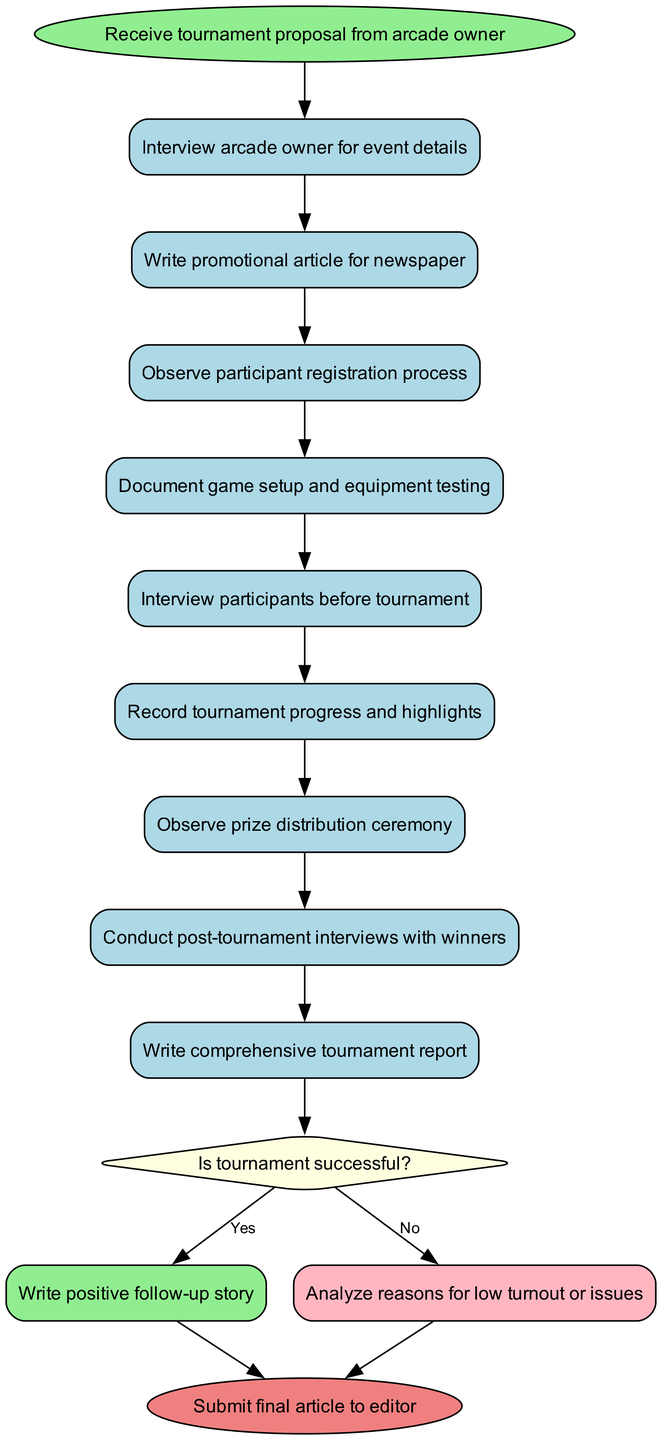What is the start node of the diagram? The start node is the first node in the flow, which is "Receive tournament proposal from arcade owner."
Answer: Receive tournament proposal from arcade owner How many activities are listed in the diagram? The diagram contains several activities, which can be counted directly in the activities section, resulting in a total of nine activities.
Answer: 9 What is the last activity before the decision node? The last activity before the decision node is "Write comprehensive tournament report," as it is the final activity leading into the decision.
Answer: Write comprehensive tournament report What happens if the tournament is successful? If the tournament is successful, the outcome in the diagram indicates that you will write a "positive follow-up story."
Answer: Write positive follow-up story Which node follows the "document game setup and equipment testing" activity? The node that follows "document game setup and equipment testing" is "interview participants before tournament," as the activities are sequenced directly.
Answer: Interview participants before tournament How many edges are there leading to the end node? There are two edges leading to the end node, one from each decision outcome (yes and no), which connect various paths to the end of the flow.
Answer: 2 What is the decision condition in the diagram? The decision condition outlined in the diagram is "Is tournament successful?" which determines the next steps based on its answer.
Answer: Is tournament successful? What happens if the tournament has low turnout? If the tournament faces low turnout, the diagram indicates that the action taken would be to "analyze reasons for low turnout or issues."
Answer: Analyze reasons for low turnout or issues Which node represents the end of the workflow? The end of the workflow is represented by the node labeled "Submit final article to editor," marking the conclusion of the process.
Answer: Submit final article to editor 